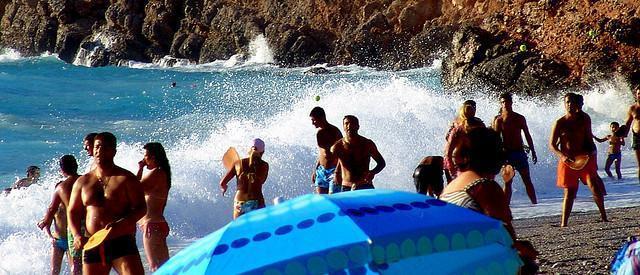How many people can be seen?
Give a very brief answer. 7. 